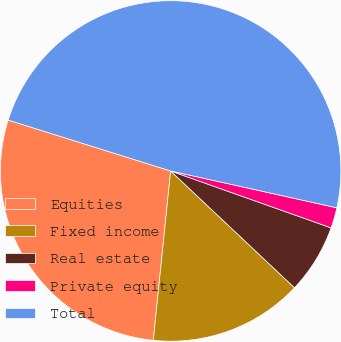<chart> <loc_0><loc_0><loc_500><loc_500><pie_chart><fcel>Equities<fcel>Fixed income<fcel>Real estate<fcel>Private equity<fcel>Total<nl><fcel>28.21%<fcel>14.59%<fcel>6.61%<fcel>1.95%<fcel>48.64%<nl></chart> 